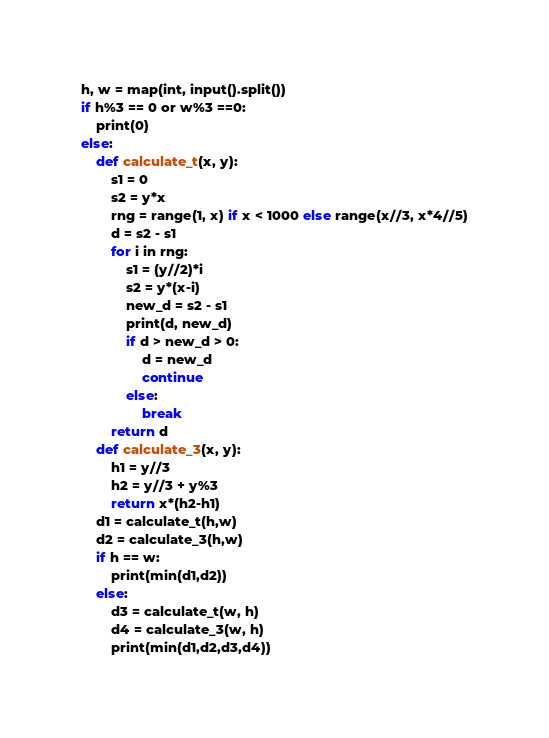Convert code to text. <code><loc_0><loc_0><loc_500><loc_500><_Python_>h, w = map(int, input().split())
if h%3 == 0 or w%3 ==0:
    print(0)
else:
    def calculate_t(x, y):
        s1 = 0
        s2 = y*x
        rng = range(1, x) if x < 1000 else range(x//3, x*4//5)
        d = s2 - s1
        for i in rng:
            s1 = (y//2)*i
            s2 = y*(x-i)
            new_d = s2 - s1
            print(d, new_d)
            if d > new_d > 0:
                d = new_d
                continue
            else:
                break
        return d
    def calculate_3(x, y):
        h1 = y//3
        h2 = y//3 + y%3
        return x*(h2-h1)
    d1 = calculate_t(h,w)
    d2 = calculate_3(h,w)
    if h == w:
        print(min(d1,d2))
    else:
        d3 = calculate_t(w, h)
        d4 = calculate_3(w, h)
        print(min(d1,d2,d3,d4))</code> 